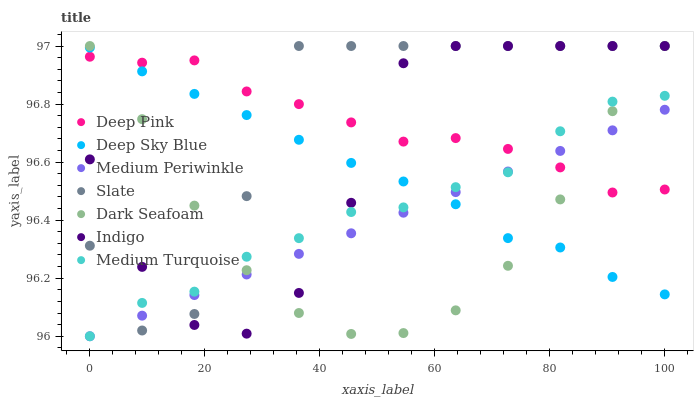Does Dark Seafoam have the minimum area under the curve?
Answer yes or no. Yes. Does Slate have the maximum area under the curve?
Answer yes or no. Yes. Does Indigo have the minimum area under the curve?
Answer yes or no. No. Does Indigo have the maximum area under the curve?
Answer yes or no. No. Is Medium Periwinkle the smoothest?
Answer yes or no. Yes. Is Indigo the roughest?
Answer yes or no. Yes. Is Medium Turquoise the smoothest?
Answer yes or no. No. Is Medium Turquoise the roughest?
Answer yes or no. No. Does Medium Turquoise have the lowest value?
Answer yes or no. Yes. Does Indigo have the lowest value?
Answer yes or no. No. Does Dark Seafoam have the highest value?
Answer yes or no. Yes. Does Medium Turquoise have the highest value?
Answer yes or no. No. Does Deep Pink intersect Dark Seafoam?
Answer yes or no. Yes. Is Deep Pink less than Dark Seafoam?
Answer yes or no. No. Is Deep Pink greater than Dark Seafoam?
Answer yes or no. No. 